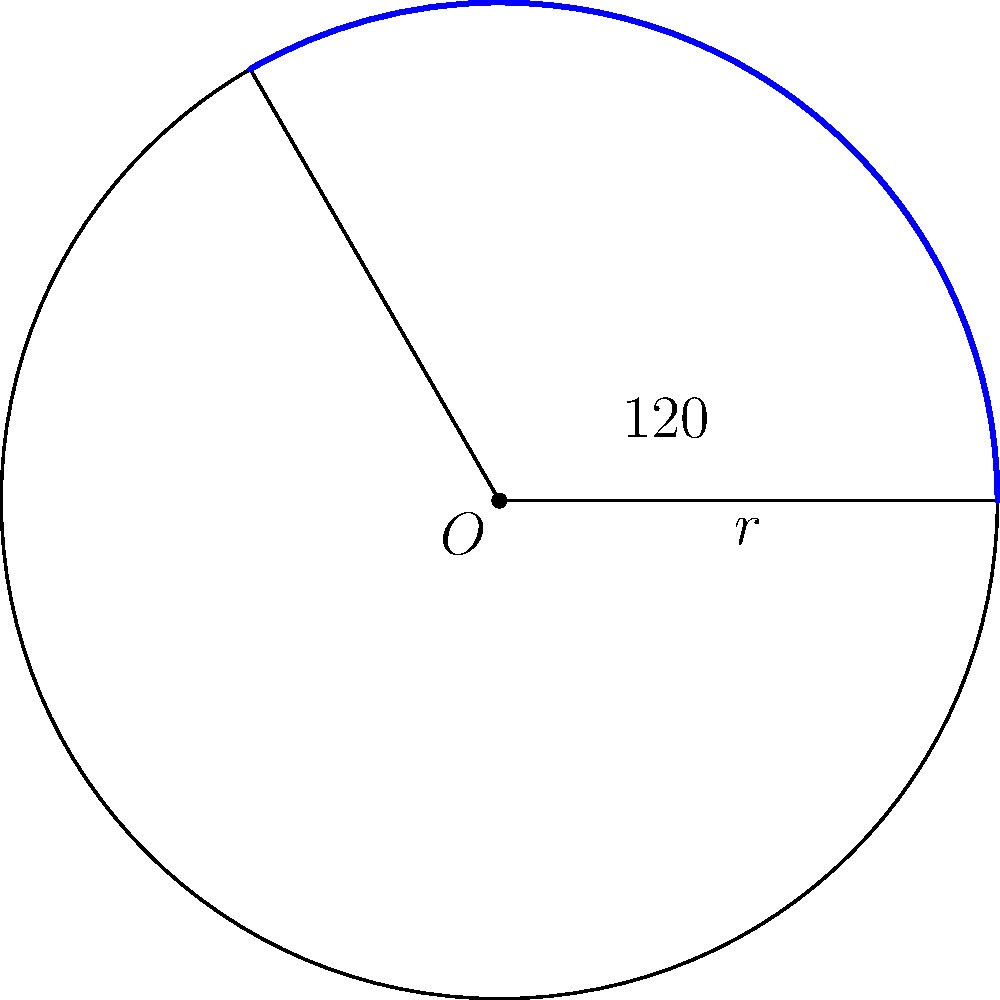In an ultrasound image of a circular structure, you observe an arc length that corresponds to a central angle of 120°. If the radius of this structure is 5 cm, what is the length of the arc? Round your answer to two decimal places. To find the length of an arc given the central angle and radius, we can follow these steps:

1) The formula for arc length is:
   $$s = r\theta$$
   where $s$ is the arc length, $r$ is the radius, and $\theta$ is the central angle in radians.

2) We are given the angle in degrees (120°), so we need to convert it to radians:
   $$\theta = 120° \times \frac{\pi}{180°} = \frac{2\pi}{3} \approx 2.0944 \text{ radians}$$

3) We are given the radius $r = 5 \text{ cm}$

4) Now we can substitute these values into our formula:
   $$s = r\theta = 5 \times \frac{2\pi}{3} = \frac{10\pi}{3} \approx 10.472 \text{ cm}$$

5) Rounding to two decimal places:
   $$s \approx 10.47 \text{ cm}$$

This approach allows for precise measurements in ultrasound imaging, ensuring accurate diagnoses and treatment plans.
Answer: 10.47 cm 